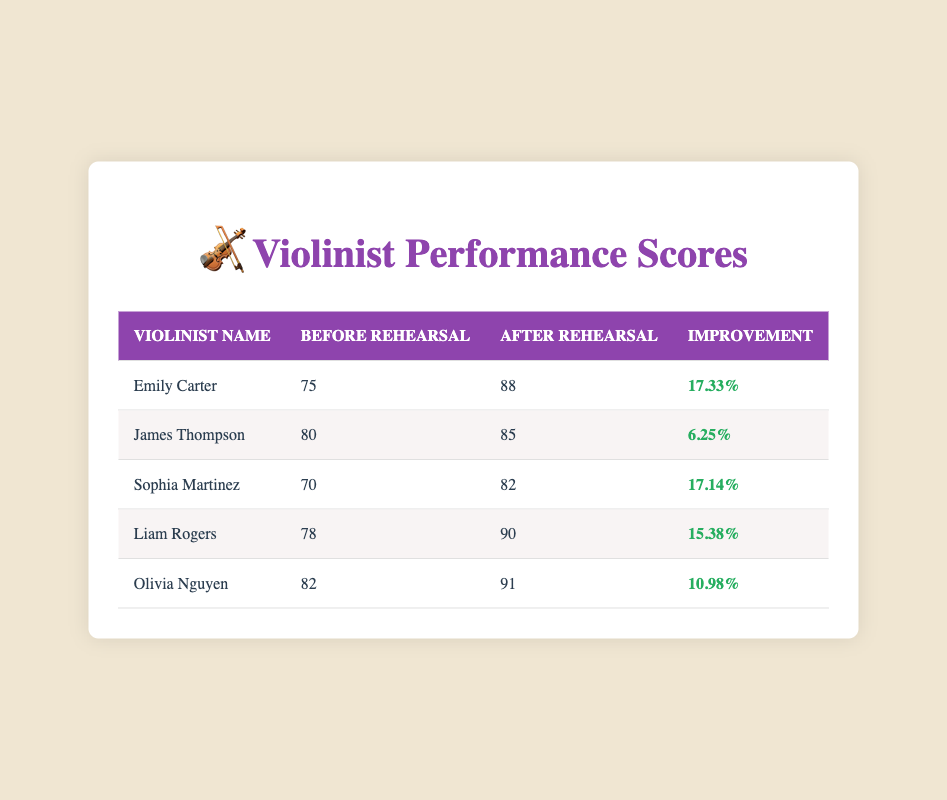What is Emily Carter's score after rehearsal? The table shows that Emily Carter had a score of 88 after rehearsal.
Answer: 88 What was the improvement percentage for Liam Rogers? According to the table, Liam Rogers experienced an improvement of 15.38%.
Answer: 15.38% Who had the lowest score before rehearsals? Looking at the before rehearsal scores, Sophia Martinez had the lowest score of 70.
Answer: Sophia Martinez What is the average improvement percentage of all violinists? To find the average improvement percentage, sum all improvement percentages: (17.33 + 6.25 + 17.14 + 15.38 + 10.98) = 66.08. Then divide by 5 (the number of violinists): 66.08 / 5 = 13.216.
Answer: 13.216 Is Olivia Nguyen's score after rehearsal higher than James Thompson's score before rehearsal? Olivia Nguyen's after rehearsal score is 91, and James Thompson's before rehearsal score is 80. Since 91 is greater than 80, the answer is yes.
Answer: Yes Which violinist showed the greatest improvement in performance scores? Comparing all improvements, Emily Carter showed the greatest improvement at 17.33%.
Answer: Emily Carter What would have happened if James Thompson's after rehearsal score were 90 instead of 85? If James Thompson's after rehearsal score were 90, we compare it to his before score of 80. This would yield a new improvement of: (90 - 80) / 80 * 100 = 12.5%.
Answer: 12.5% What is the difference in scores before rehearsal between Liam Rogers and Sophia Martinez? Liam Rogers had a score of 78 before rehearsal, while Sophia Martinez had a score of 70. The difference is 78 - 70 = 8.
Answer: 8 How many violinists had an improvement percentage of over 15%? Referring to the improvement percentages, both Emily Carter (17.33%) and Liam Rogers (15.38%) are over 15%, making a total of 2 violinists.
Answer: 2 